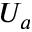<formula> <loc_0><loc_0><loc_500><loc_500>U _ { a }</formula> 